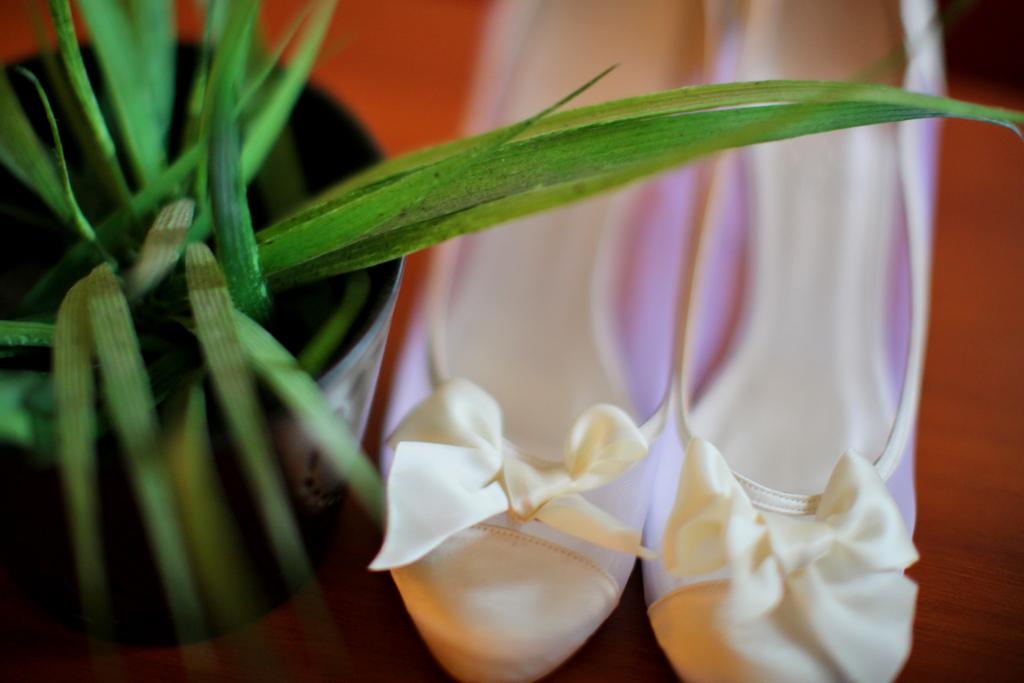What type of plant is in the image? There is a house plant in the image. What is located beside the house plant? There is a pair of footwear beside the house plant. How many eyes can be seen on the house plant in the image? House plants do not have eyes, so it is not possible to see any eyes on the house plant in the image. What type of line is visible connecting the house plant and the footwear in the image? There is no line connecting the house plant and the footwear in the image. What is the purpose of the umbrella in the image? There is no umbrella present in the image. 